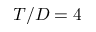<formula> <loc_0><loc_0><loc_500><loc_500>T / D = 4</formula> 